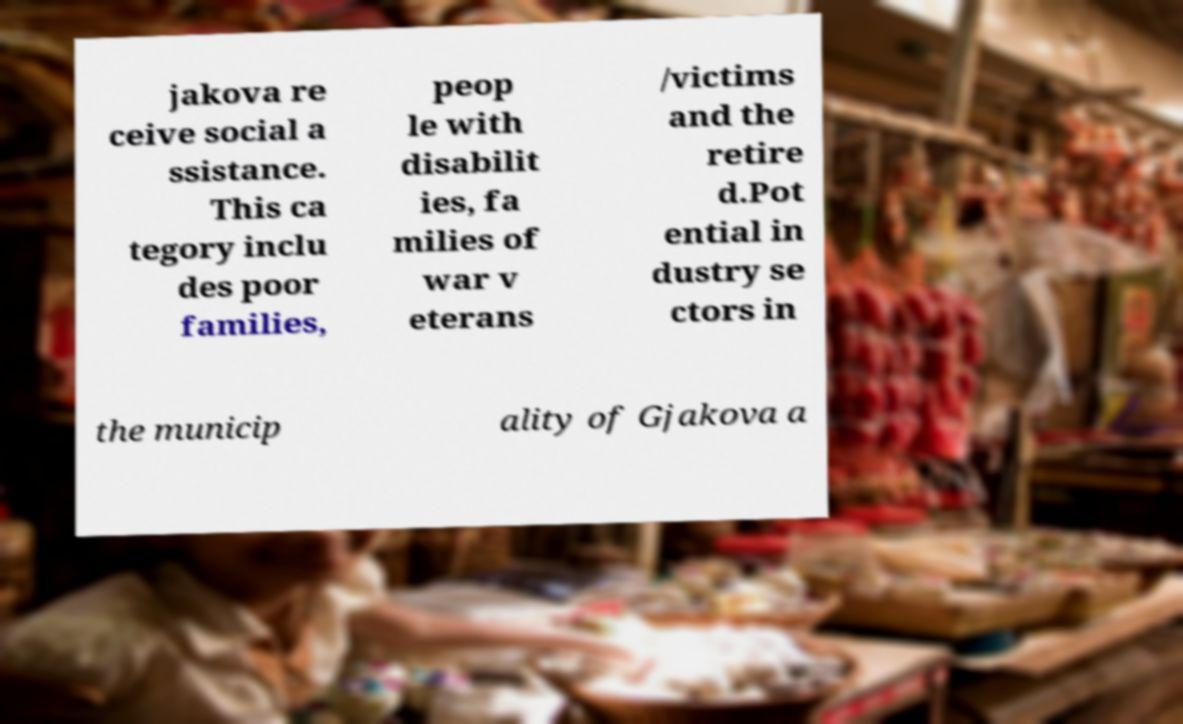There's text embedded in this image that I need extracted. Can you transcribe it verbatim? jakova re ceive social a ssistance. This ca tegory inclu des poor families, peop le with disabilit ies, fa milies of war v eterans /victims and the retire d.Pot ential in dustry se ctors in the municip ality of Gjakova a 